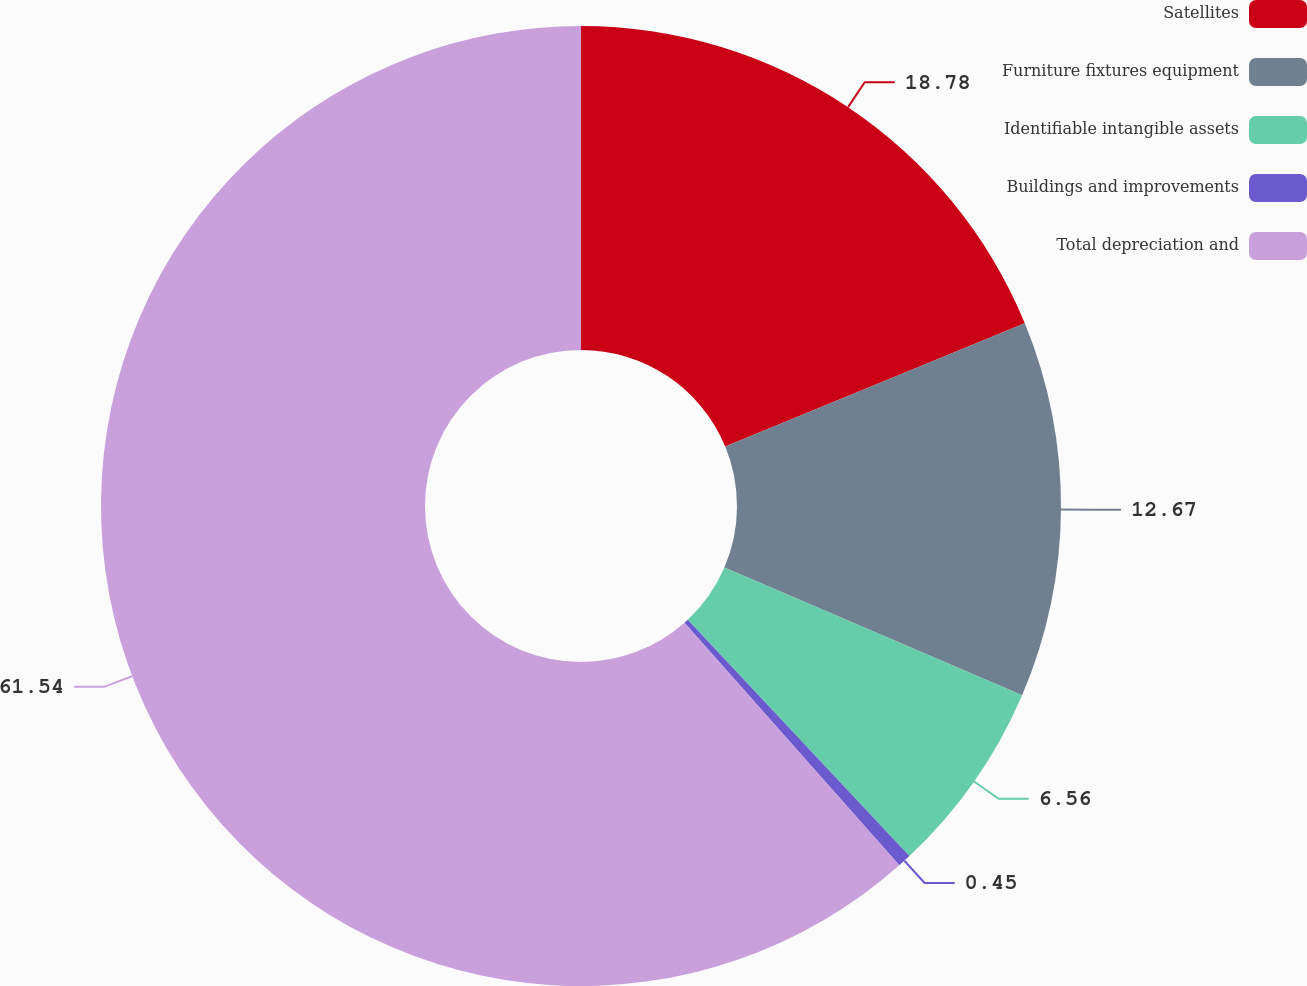Convert chart to OTSL. <chart><loc_0><loc_0><loc_500><loc_500><pie_chart><fcel>Satellites<fcel>Furniture fixtures equipment<fcel>Identifiable intangible assets<fcel>Buildings and improvements<fcel>Total depreciation and<nl><fcel>18.78%<fcel>12.67%<fcel>6.56%<fcel>0.45%<fcel>61.54%<nl></chart> 